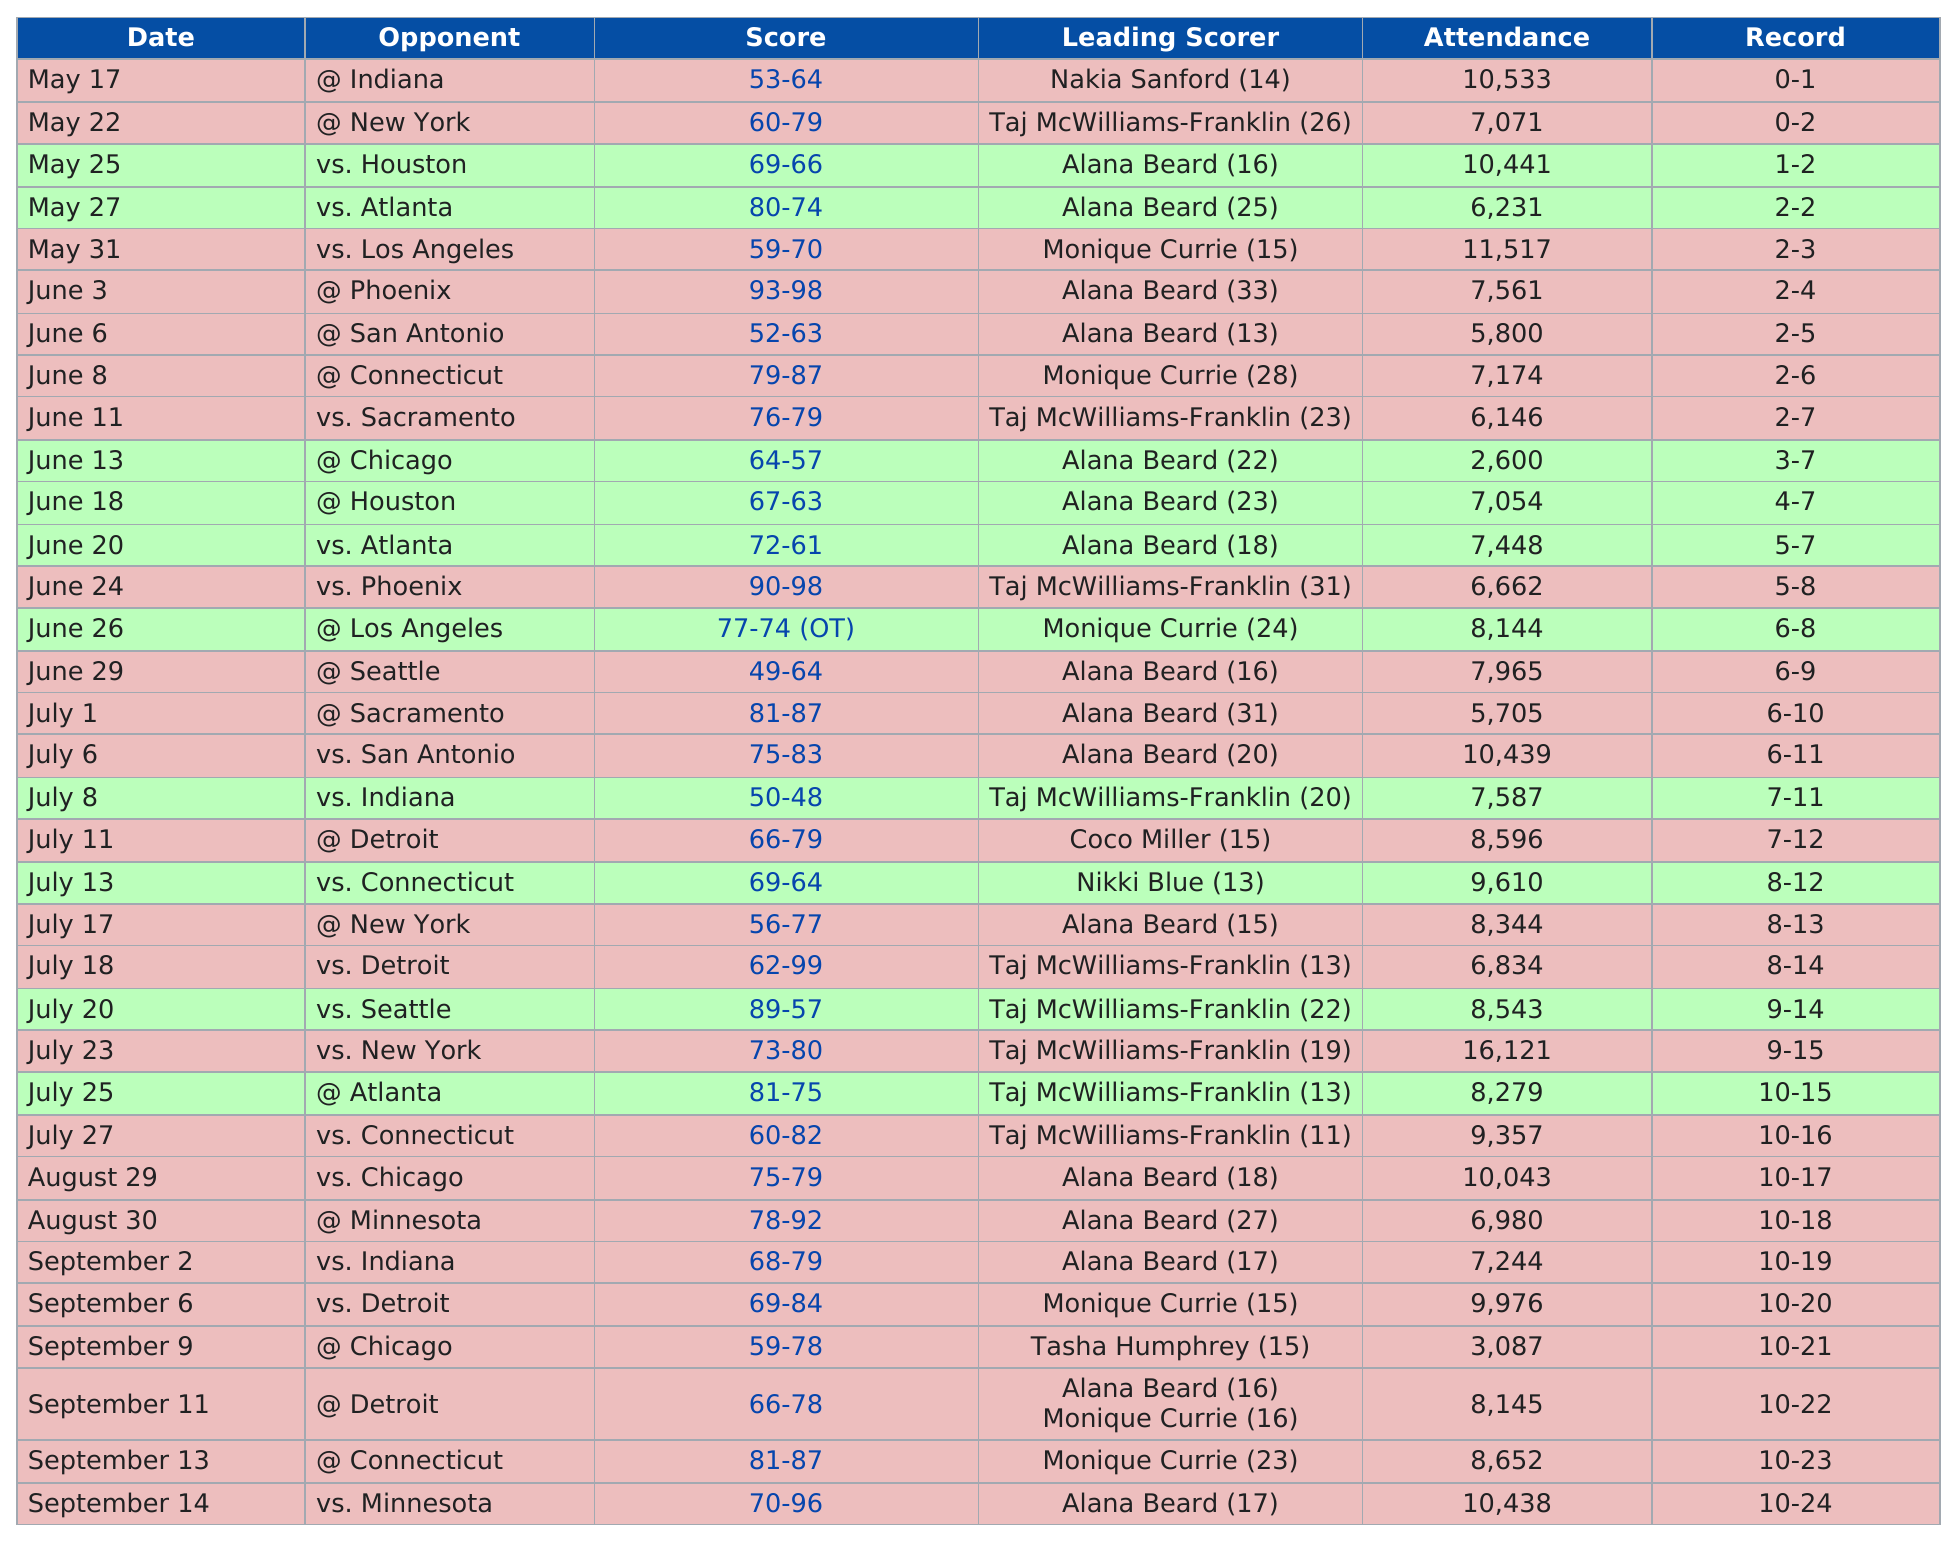Indicate a few pertinent items in this graphic. We do not have enough information to answer the question "how many games had attendance with at least 10,000 people? 7.." can you please provide more context or information? The leading scorer, with the least amount of points scored, achieved only 11. The Washington Mystics scored 76 points against the Sacramento Kings on June 11. On June 24th, approximately 6,662 people attended the game. The score after the season opener was 53-64, a substantial defeat for the home team. 